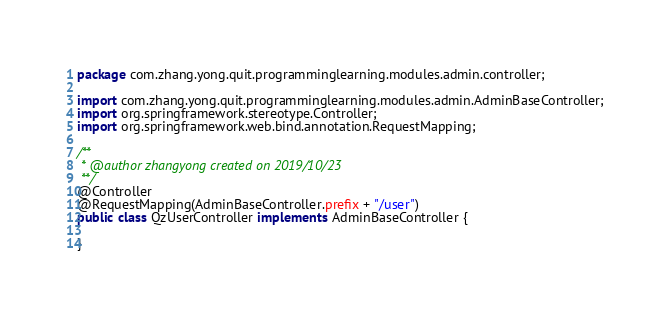Convert code to text. <code><loc_0><loc_0><loc_500><loc_500><_Java_>package com.zhang.yong.quit.programminglearning.modules.admin.controller;

import com.zhang.yong.quit.programminglearning.modules.admin.AdminBaseController;
import org.springframework.stereotype.Controller;
import org.springframework.web.bind.annotation.RequestMapping;

/**
 * @author zhangyong created on 2019/10/23
 **/
@Controller
@RequestMapping(AdminBaseController.prefix + "/user")
public class QzUserController implements AdminBaseController {

}
</code> 